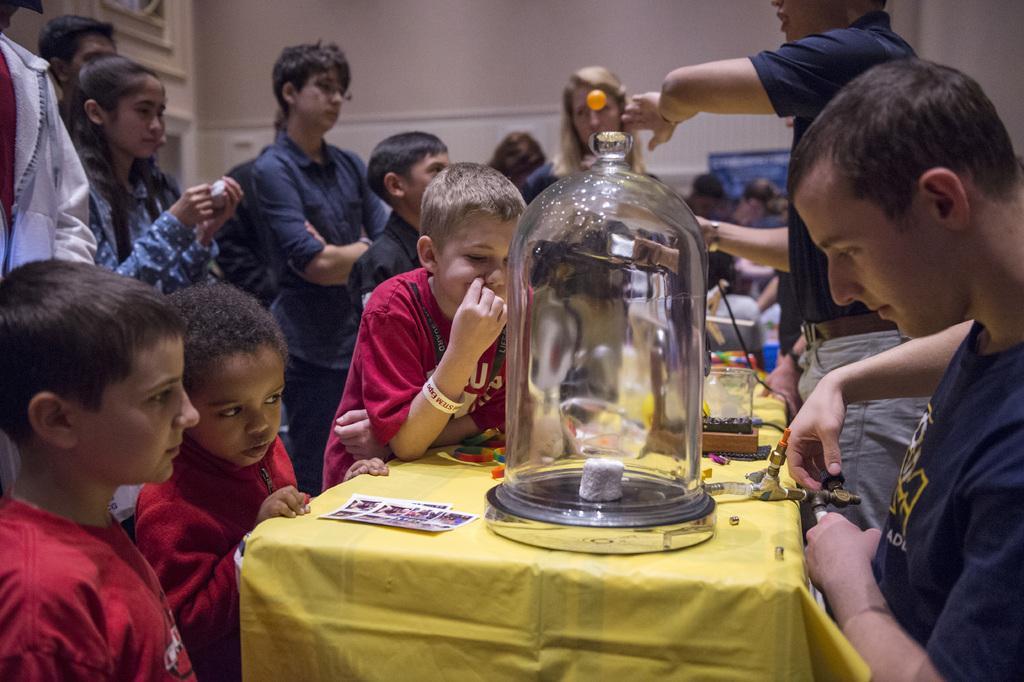In one or two sentences, can you explain what this image depicts? This is a picture from a science exhibition. In the center of the picture there is a table, on the table there is a glass object and cable. On the right there are many. On the left there are kids. In the background of the right there are many people. In the background there is a wall. 